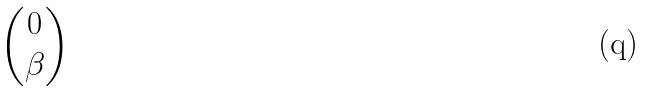Convert formula to latex. <formula><loc_0><loc_0><loc_500><loc_500>\begin{pmatrix} 0 \\ \beta \end{pmatrix}</formula> 